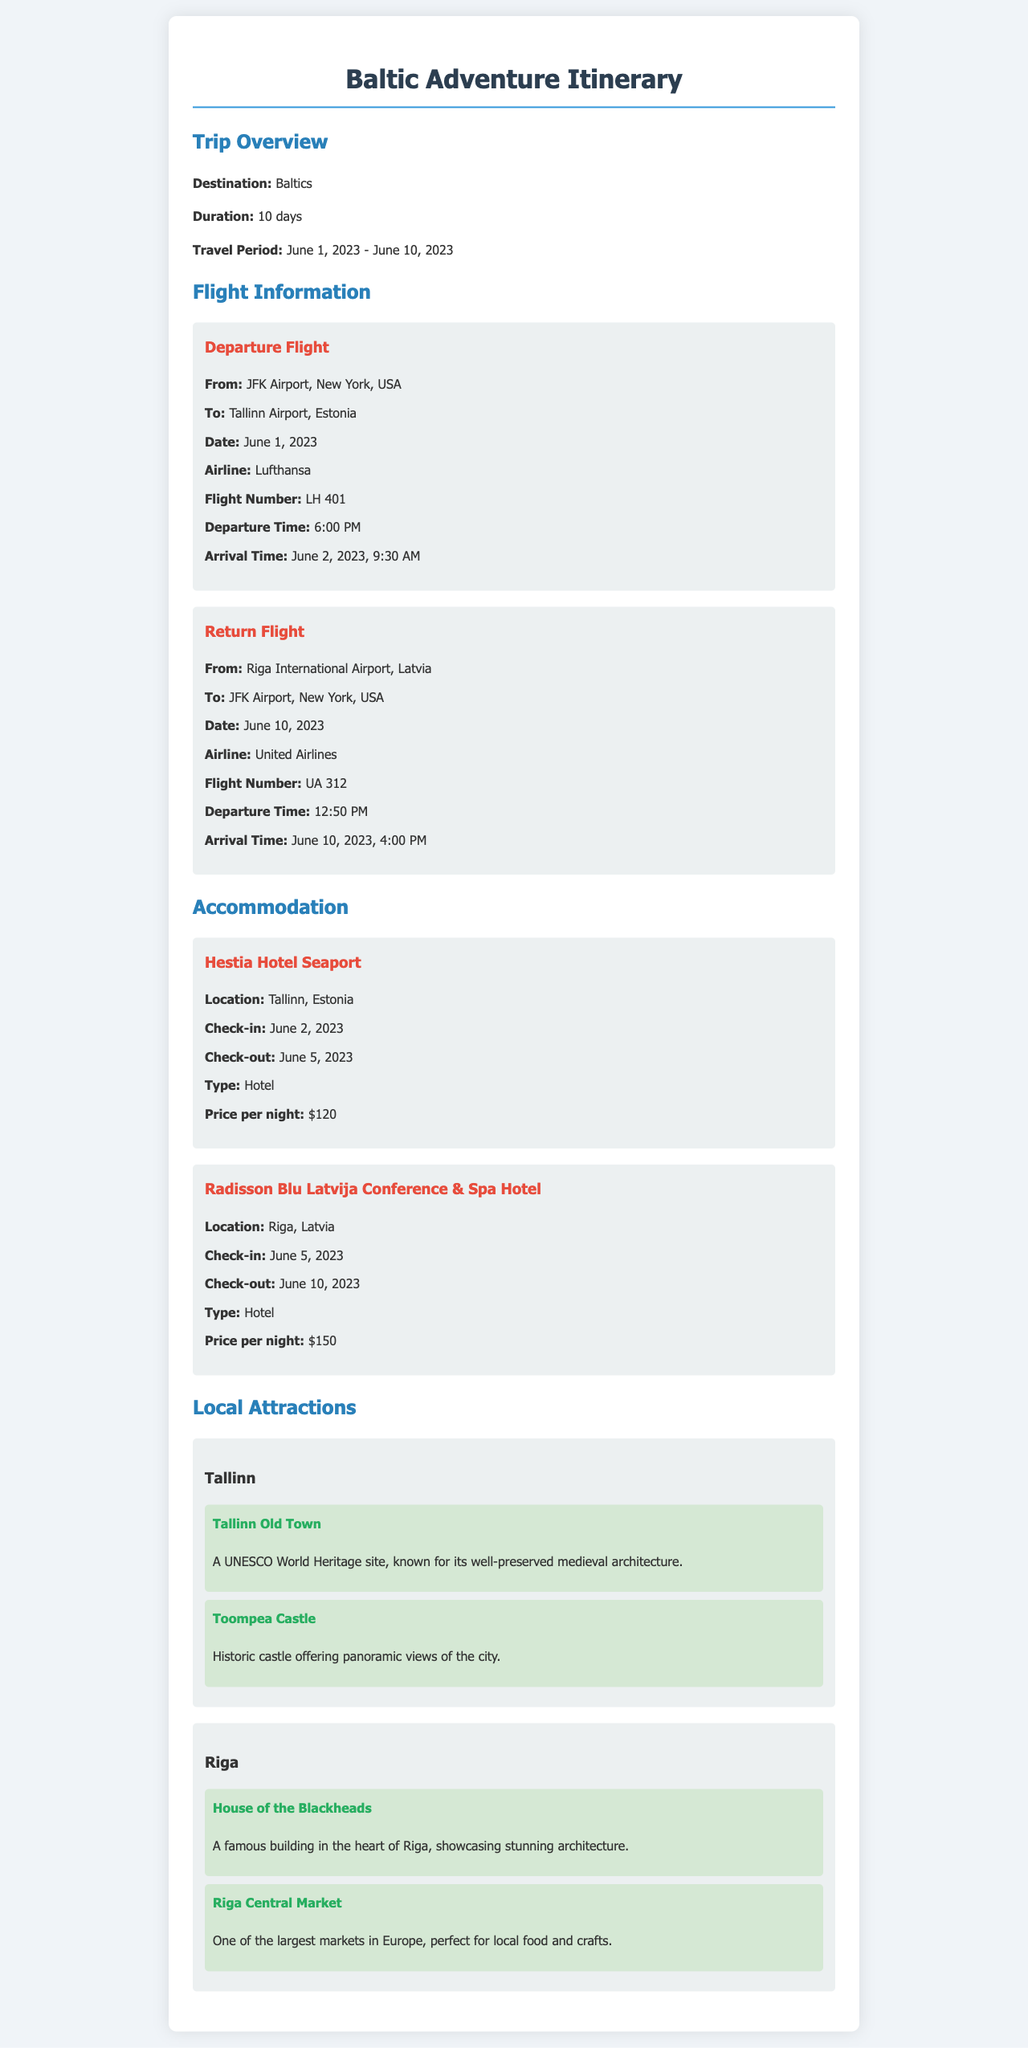What is the duration of the trip? The duration of the trip is stated in the overview section, which is 10 days.
Answer: 10 days What airline is used for the departure flight? The document specifies that Lufthansa is the airline for the departure flight.
Answer: Lufthansa What is the check-in date at Hestia Hotel Seaport? The check-in date is provided under the accommodation section for Hestia Hotel Seaport, which is June 2, 2023.
Answer: June 2, 2023 How much does the Radisson Blu Latvija Conference & Spa Hotel charge per night? The price per night for this hotel is mentioned in the accommodation section as $150.
Answer: $150 Which attraction is a UNESCO World Heritage site? This information can be deduced from the attractions listed under Tallinn, where Tallinn Old Town is specifically mentioned as a UNESCO World Heritage site.
Answer: Tallinn Old Town What is the arrival time for the return flight? The arrival time for the return flight is stated to be June 10, 2023, at 4:00 PM.
Answer: June 10, 2023, 4:00 PM Which airport does the return flight leave from? The document clearly states that the return flight departs from Riga International Airport, Latvia.
Answer: Riga International Airport What type of accommodation is Hestia Hotel Seaport? The accommodation type for Hestia Hotel Seaport is specified, indicating that it is a hotel.
Answer: Hotel 